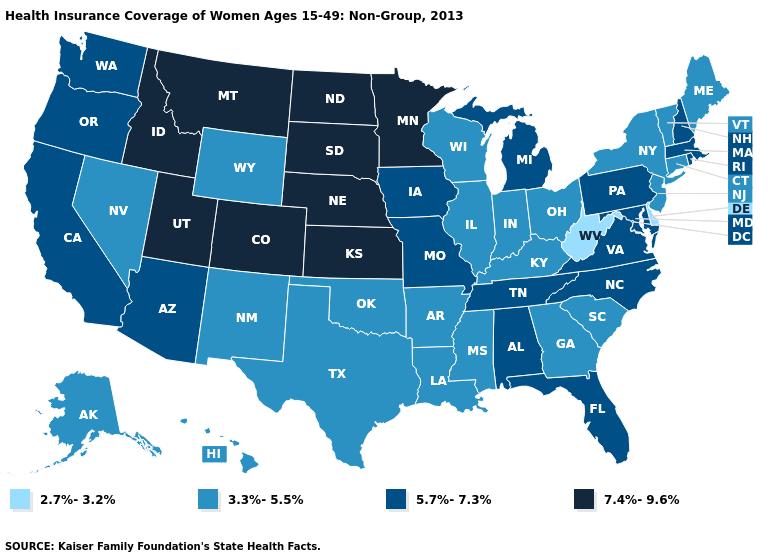Name the states that have a value in the range 5.7%-7.3%?
Concise answer only. Alabama, Arizona, California, Florida, Iowa, Maryland, Massachusetts, Michigan, Missouri, New Hampshire, North Carolina, Oregon, Pennsylvania, Rhode Island, Tennessee, Virginia, Washington. Name the states that have a value in the range 7.4%-9.6%?
Give a very brief answer. Colorado, Idaho, Kansas, Minnesota, Montana, Nebraska, North Dakota, South Dakota, Utah. Does Tennessee have the same value as California?
Quick response, please. Yes. Name the states that have a value in the range 5.7%-7.3%?
Give a very brief answer. Alabama, Arizona, California, Florida, Iowa, Maryland, Massachusetts, Michigan, Missouri, New Hampshire, North Carolina, Oregon, Pennsylvania, Rhode Island, Tennessee, Virginia, Washington. Among the states that border Massachusetts , which have the highest value?
Quick response, please. New Hampshire, Rhode Island. Name the states that have a value in the range 7.4%-9.6%?
Quick response, please. Colorado, Idaho, Kansas, Minnesota, Montana, Nebraska, North Dakota, South Dakota, Utah. Among the states that border Idaho , does Utah have the lowest value?
Quick response, please. No. Which states hav the highest value in the MidWest?
Short answer required. Kansas, Minnesota, Nebraska, North Dakota, South Dakota. What is the highest value in states that border Alabama?
Write a very short answer. 5.7%-7.3%. Name the states that have a value in the range 3.3%-5.5%?
Write a very short answer. Alaska, Arkansas, Connecticut, Georgia, Hawaii, Illinois, Indiana, Kentucky, Louisiana, Maine, Mississippi, Nevada, New Jersey, New Mexico, New York, Ohio, Oklahoma, South Carolina, Texas, Vermont, Wisconsin, Wyoming. Name the states that have a value in the range 2.7%-3.2%?
Write a very short answer. Delaware, West Virginia. Among the states that border Virginia , does West Virginia have the highest value?
Quick response, please. No. Name the states that have a value in the range 7.4%-9.6%?
Quick response, please. Colorado, Idaho, Kansas, Minnesota, Montana, Nebraska, North Dakota, South Dakota, Utah. Among the states that border Michigan , which have the highest value?
Quick response, please. Indiana, Ohio, Wisconsin. Does Oklahoma have the lowest value in the South?
Answer briefly. No. 